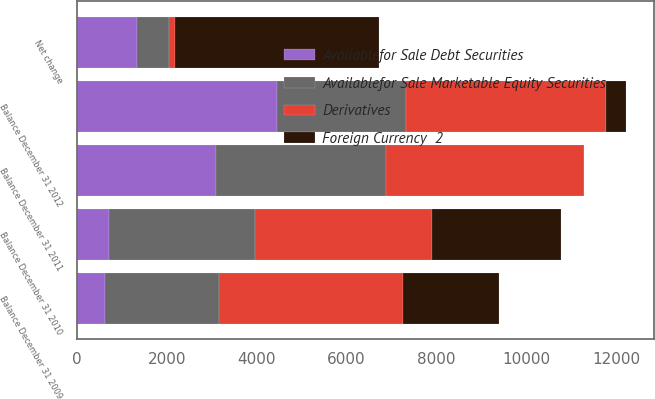Convert chart to OTSL. <chart><loc_0><loc_0><loc_500><loc_500><stacked_bar_chart><ecel><fcel>Balance December 31 2009<fcel>Net change<fcel>Balance December 31 2010<fcel>Balance December 31 2011<fcel>Balance December 31 2012<nl><fcel>Availablefor Sale Debt Securities<fcel>628<fcel>1342<fcel>714<fcel>3100<fcel>4443<nl><fcel>Foreign Currency  2<fcel>2129<fcel>4530<fcel>2869<fcel>3<fcel>462<nl><fcel>Availablefor Sale Marketable Equity Securities<fcel>2535<fcel>701<fcel>3236<fcel>3785<fcel>2869<nl><fcel>Derivatives<fcel>4092<fcel>145<fcel>3947<fcel>4391<fcel>4456<nl></chart> 